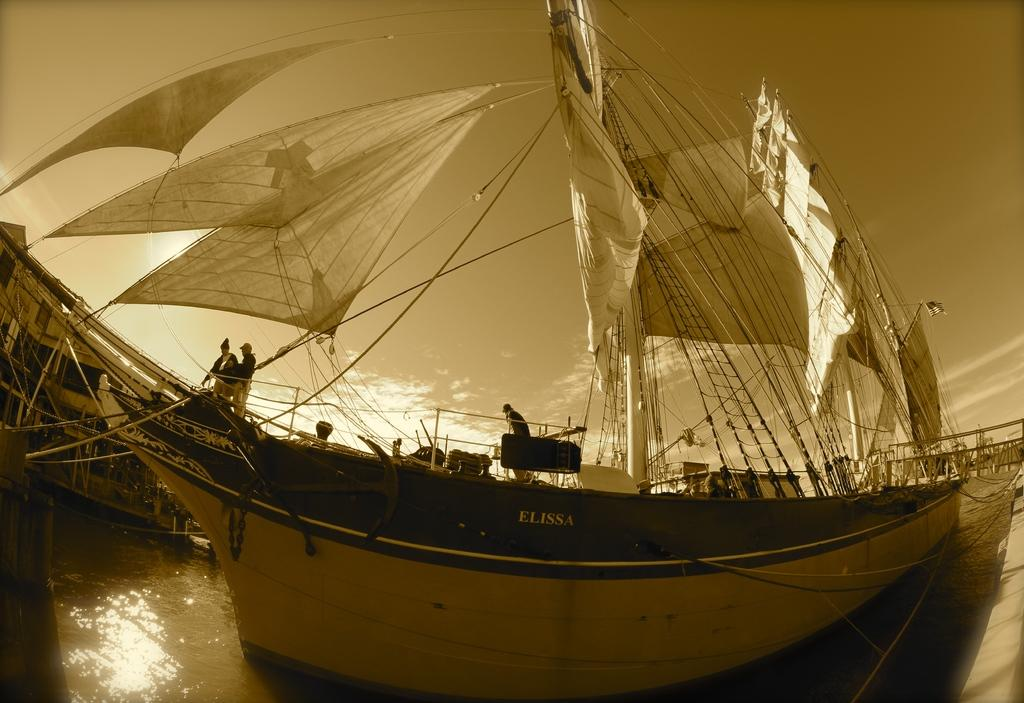What is the main subject in the center of the image? There is a ship in the center of the image. Are there any people on the ship? Yes, there are people in the ship. What is the body of water beneath the ship? There is a river at the bottom of the image. What can be seen in the background of the image? The sky is visible in the background of the image. What type of pleasure can be seen on the people's chins in the image? There is no indication of pleasure or any facial expressions on the people's chins in the image. Additionally, there is no mention of chins in the provided facts. 